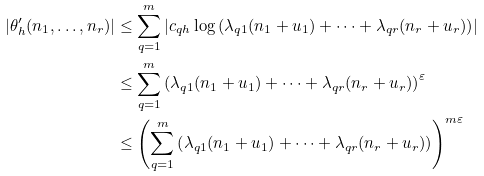<formula> <loc_0><loc_0><loc_500><loc_500>\left | \theta _ { h } ^ { \prime } ( n _ { 1 } , \dots , n _ { r } ) \right | & \leq \sum _ { q = 1 } ^ { m } \left | c _ { q h } \log \left ( \lambda _ { q 1 } ( n _ { 1 } + u _ { 1 } ) + \cdots + \lambda _ { q r } ( n _ { r } + u _ { r } ) \right ) \right | \\ & \leq \sum _ { q = 1 } ^ { m } \left ( \lambda _ { q 1 } ( n _ { 1 } + u _ { 1 } ) + \cdots + \lambda _ { q r } ( n _ { r } + u _ { r } ) \right ) ^ { \varepsilon } \\ & \leq \left ( \sum _ { q = 1 } ^ { m } \left ( \lambda _ { q 1 } ( n _ { 1 } + u _ { 1 } ) + \cdots + \lambda _ { q r } ( n _ { r } + u _ { r } ) \right ) \right ) ^ { m \varepsilon }</formula> 